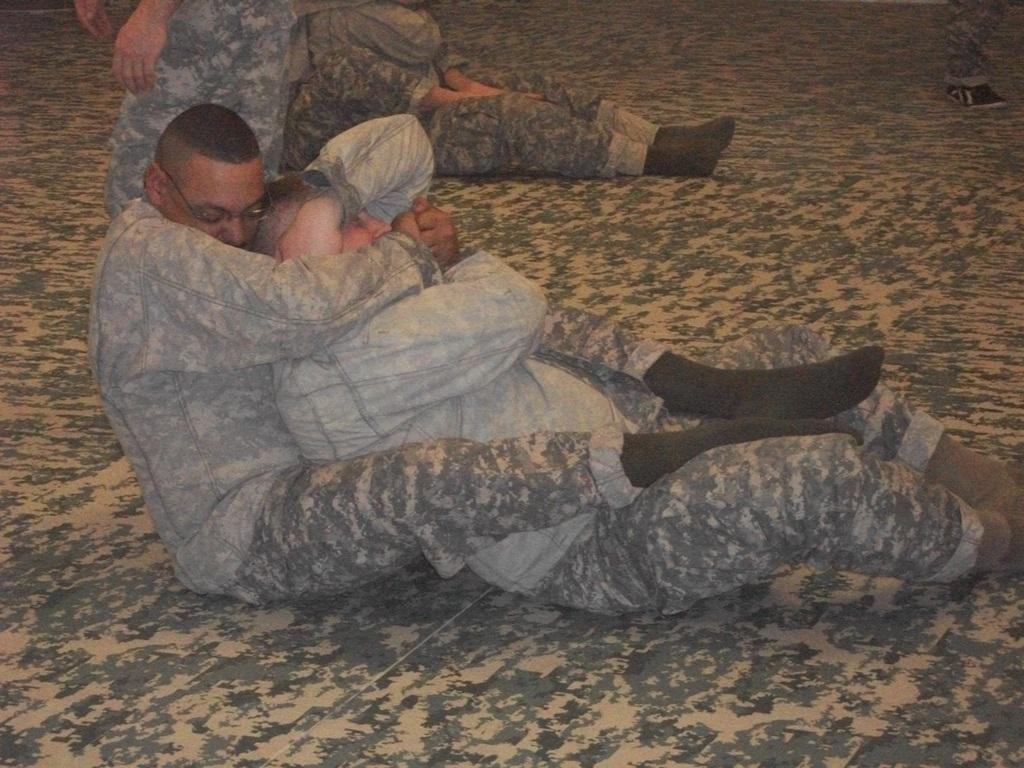What are the people in the image doing? The people in the image are sitting on the ground. Can you describe any specific body parts visible in the image? Yes, there is a leg of a person visible at the right side of the image. What type of cap is being advertised in the image? There is no cap or advertisement present in the image; it only shows people sitting on the ground. 